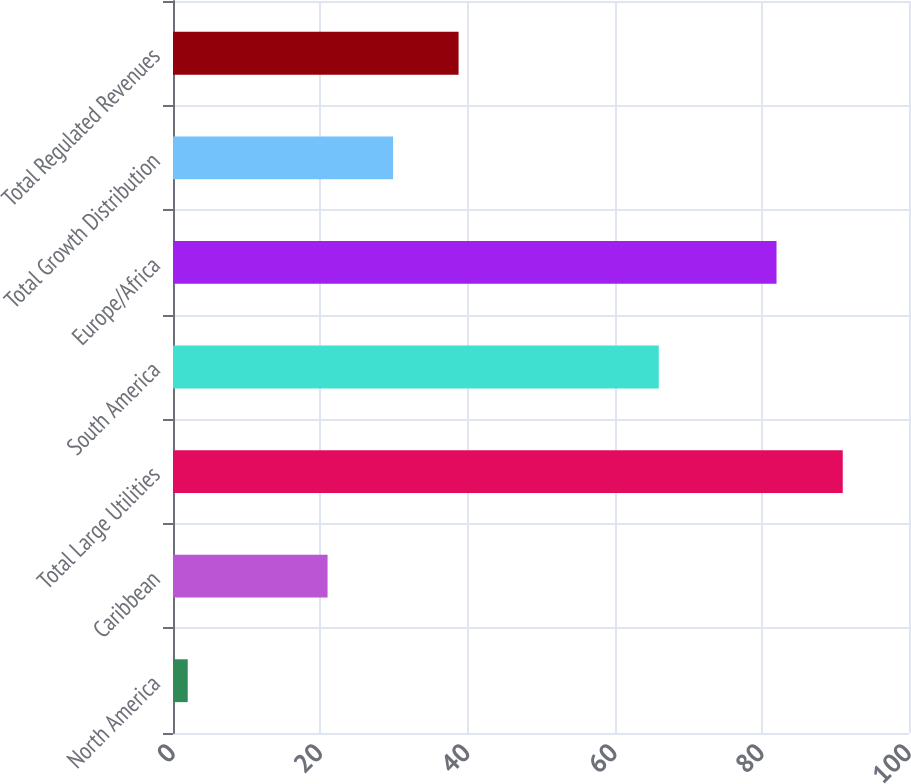<chart> <loc_0><loc_0><loc_500><loc_500><bar_chart><fcel>North America<fcel>Caribbean<fcel>Total Large Utilities<fcel>South America<fcel>Europe/Africa<fcel>Total Growth Distribution<fcel>Total Regulated Revenues<nl><fcel>2<fcel>21<fcel>91<fcel>66<fcel>82<fcel>29.9<fcel>38.8<nl></chart> 